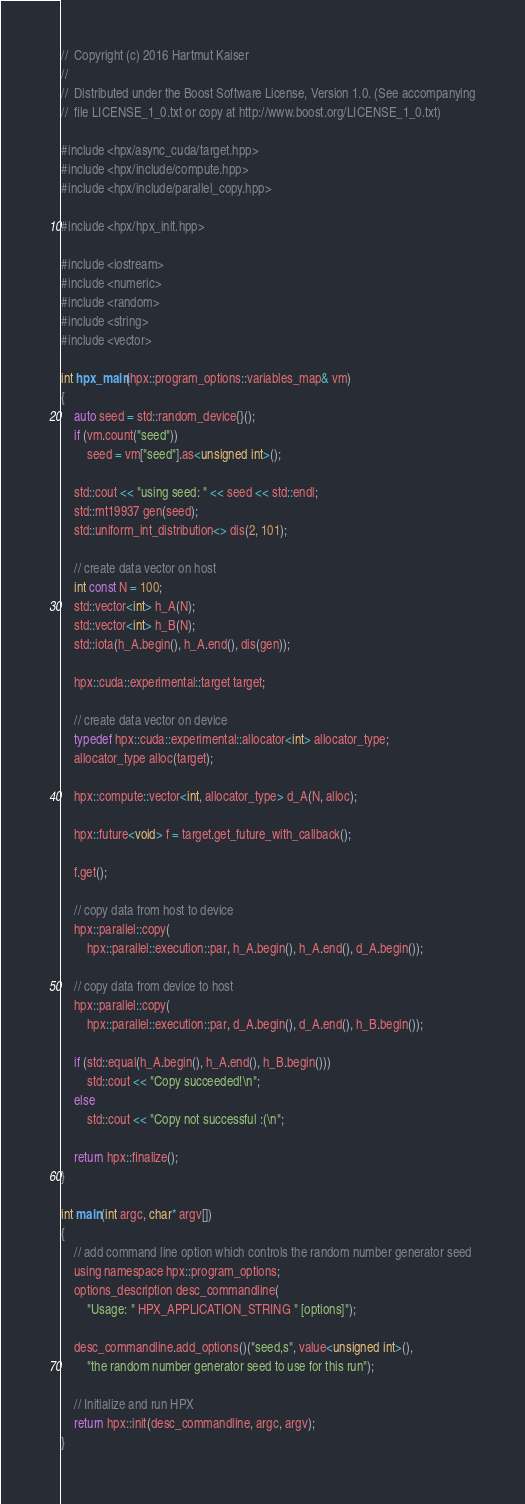Convert code to text. <code><loc_0><loc_0><loc_500><loc_500><_Cuda_>//  Copyright (c) 2016 Hartmut Kaiser
//
//  Distributed under the Boost Software License, Version 1.0. (See accompanying
//  file LICENSE_1_0.txt or copy at http://www.boost.org/LICENSE_1_0.txt)

#include <hpx/async_cuda/target.hpp>
#include <hpx/include/compute.hpp>
#include <hpx/include/parallel_copy.hpp>

#include <hpx/hpx_init.hpp>

#include <iostream>
#include <numeric>
#include <random>
#include <string>
#include <vector>

int hpx_main(hpx::program_options::variables_map& vm)
{
    auto seed = std::random_device{}();
    if (vm.count("seed"))
        seed = vm["seed"].as<unsigned int>();

    std::cout << "using seed: " << seed << std::endl;
    std::mt19937 gen(seed);
    std::uniform_int_distribution<> dis(2, 101);

    // create data vector on host
    int const N = 100;
    std::vector<int> h_A(N);
    std::vector<int> h_B(N);
    std::iota(h_A.begin(), h_A.end(), dis(gen));

    hpx::cuda::experimental::target target;

    // create data vector on device
    typedef hpx::cuda::experimental::allocator<int> allocator_type;
    allocator_type alloc(target);

    hpx::compute::vector<int, allocator_type> d_A(N, alloc);

    hpx::future<void> f = target.get_future_with_callback();

    f.get();

    // copy data from host to device
    hpx::parallel::copy(
        hpx::parallel::execution::par, h_A.begin(), h_A.end(), d_A.begin());

    // copy data from device to host
    hpx::parallel::copy(
        hpx::parallel::execution::par, d_A.begin(), d_A.end(), h_B.begin());

    if (std::equal(h_A.begin(), h_A.end(), h_B.begin()))
        std::cout << "Copy succeeded!\n";
    else
        std::cout << "Copy not successful :(\n";

    return hpx::finalize();
}

int main(int argc, char* argv[])
{
    // add command line option which controls the random number generator seed
    using namespace hpx::program_options;
    options_description desc_commandline(
        "Usage: " HPX_APPLICATION_STRING " [options]");

    desc_commandline.add_options()("seed,s", value<unsigned int>(),
        "the random number generator seed to use for this run");

    // Initialize and run HPX
    return hpx::init(desc_commandline, argc, argv);
}
</code> 